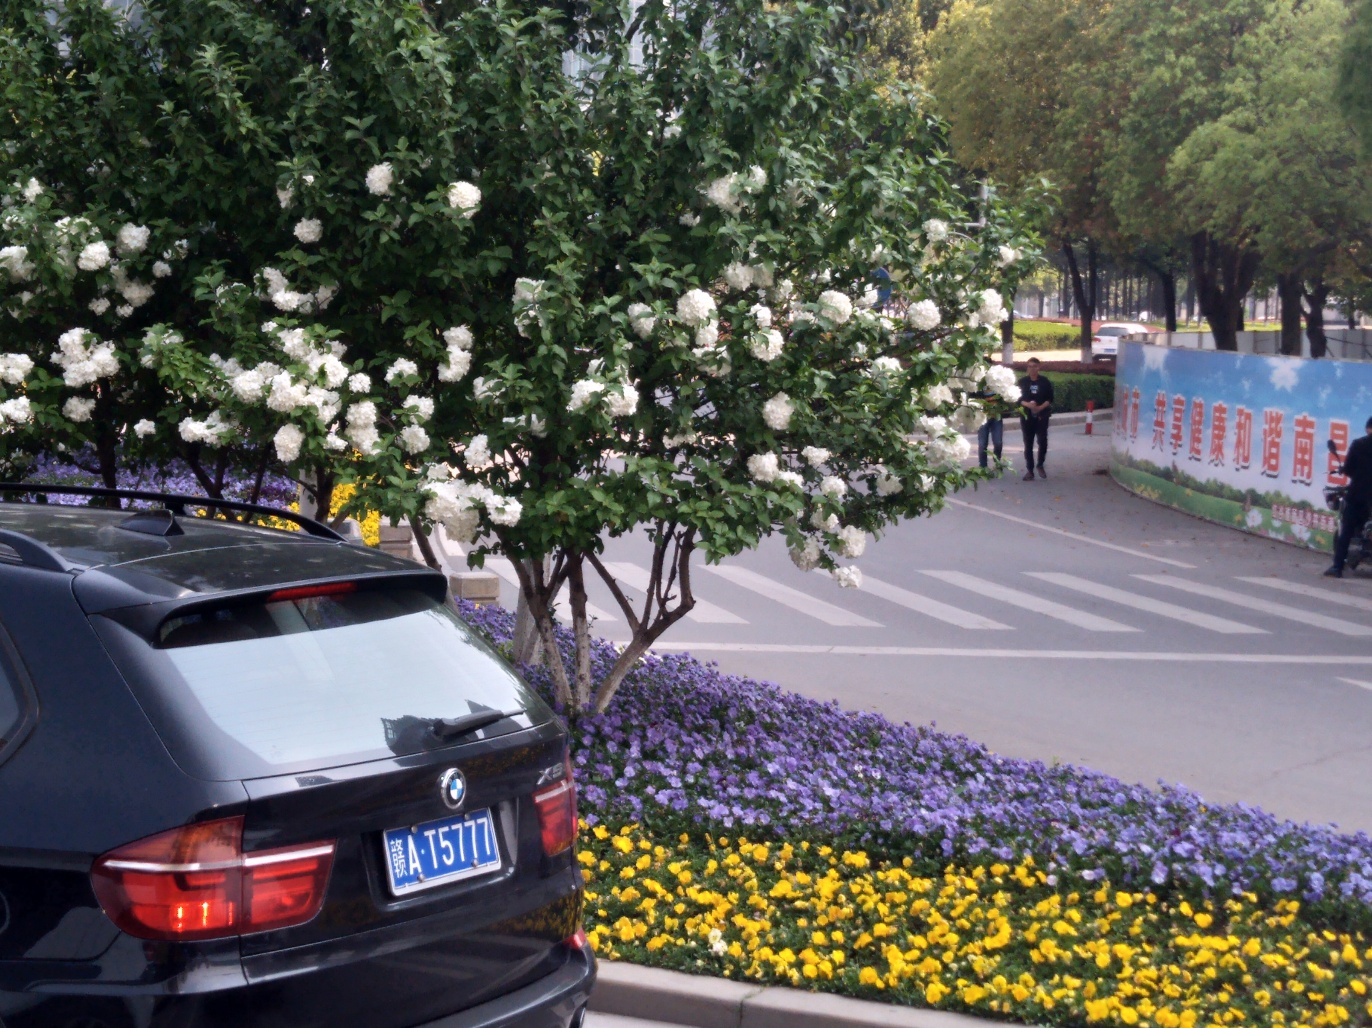What type of flowers are shown in the image? The image displays a vibrant collection of flowers including white blooms that appear to be a variety of rose, and beds of purple and yellow pansies. The flowers are well-maintained, suggesting that this is a cared-for urban or garden space. 